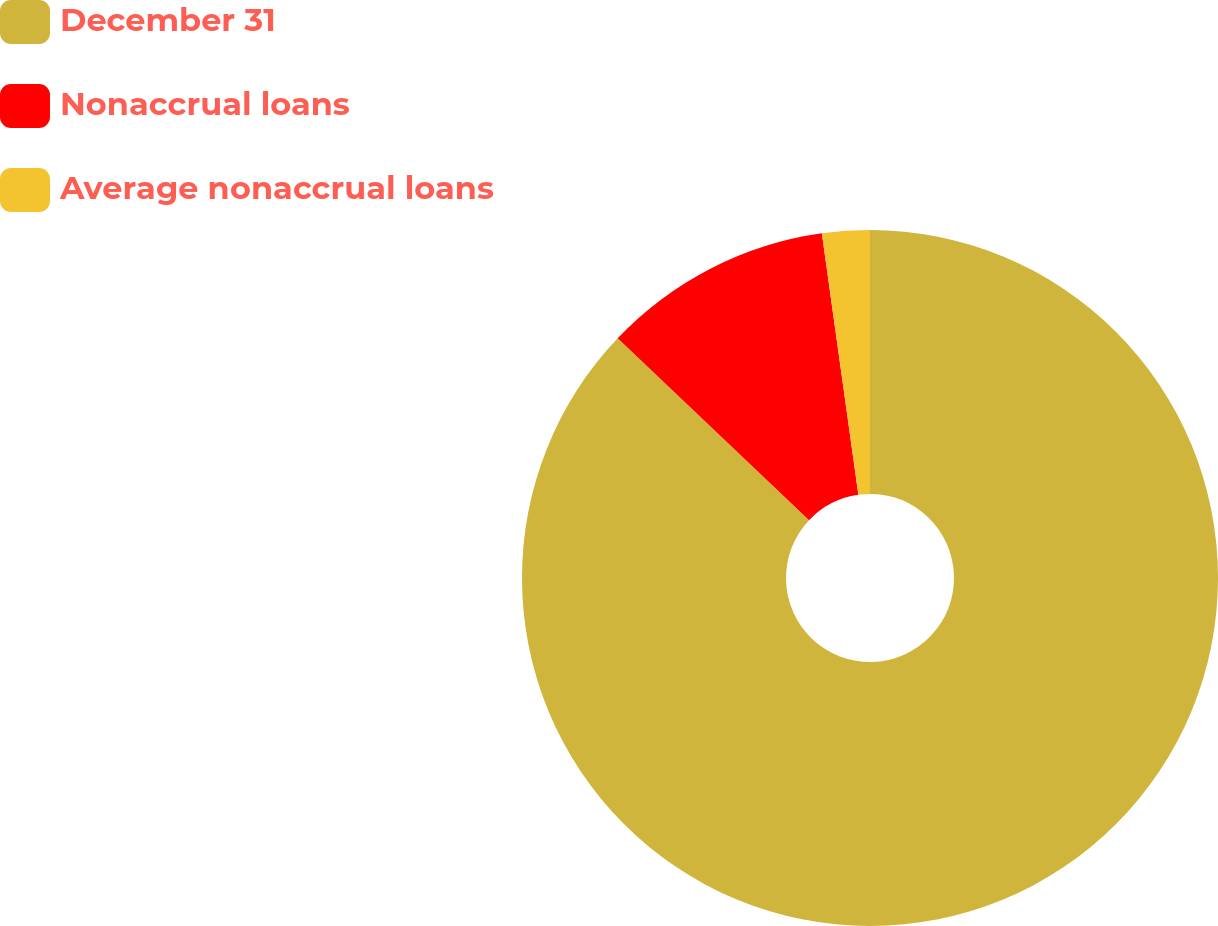Convert chart to OTSL. <chart><loc_0><loc_0><loc_500><loc_500><pie_chart><fcel>December 31<fcel>Nonaccrual loans<fcel>Average nonaccrual loans<nl><fcel>87.09%<fcel>10.7%<fcel>2.21%<nl></chart> 